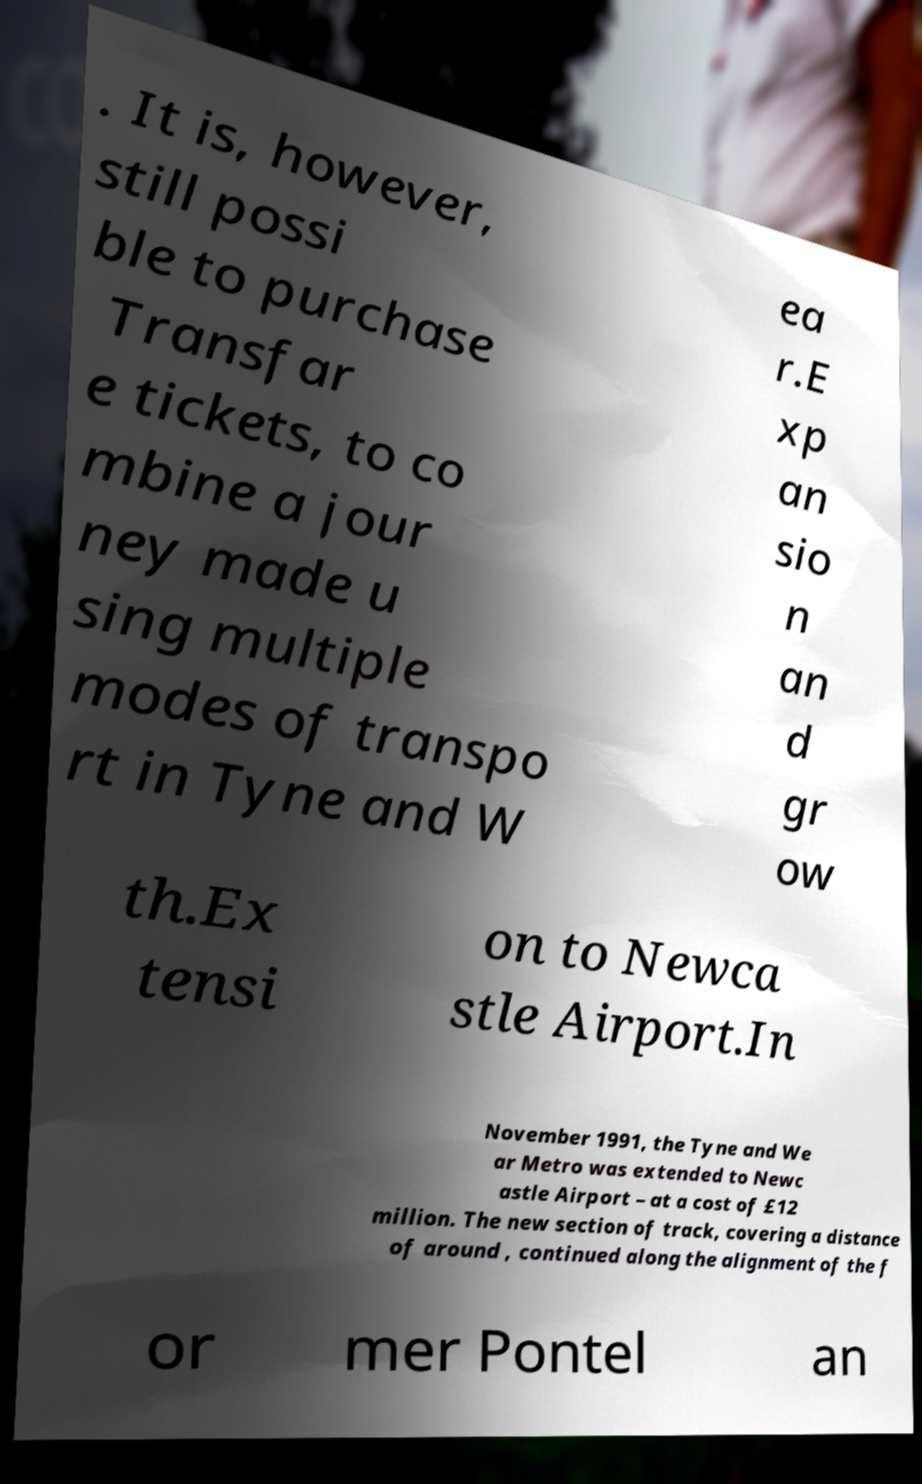For documentation purposes, I need the text within this image transcribed. Could you provide that? . It is, however, still possi ble to purchase Transfar e tickets, to co mbine a jour ney made u sing multiple modes of transpo rt in Tyne and W ea r.E xp an sio n an d gr ow th.Ex tensi on to Newca stle Airport.In November 1991, the Tyne and We ar Metro was extended to Newc astle Airport – at a cost of £12 million. The new section of track, covering a distance of around , continued along the alignment of the f or mer Pontel an 